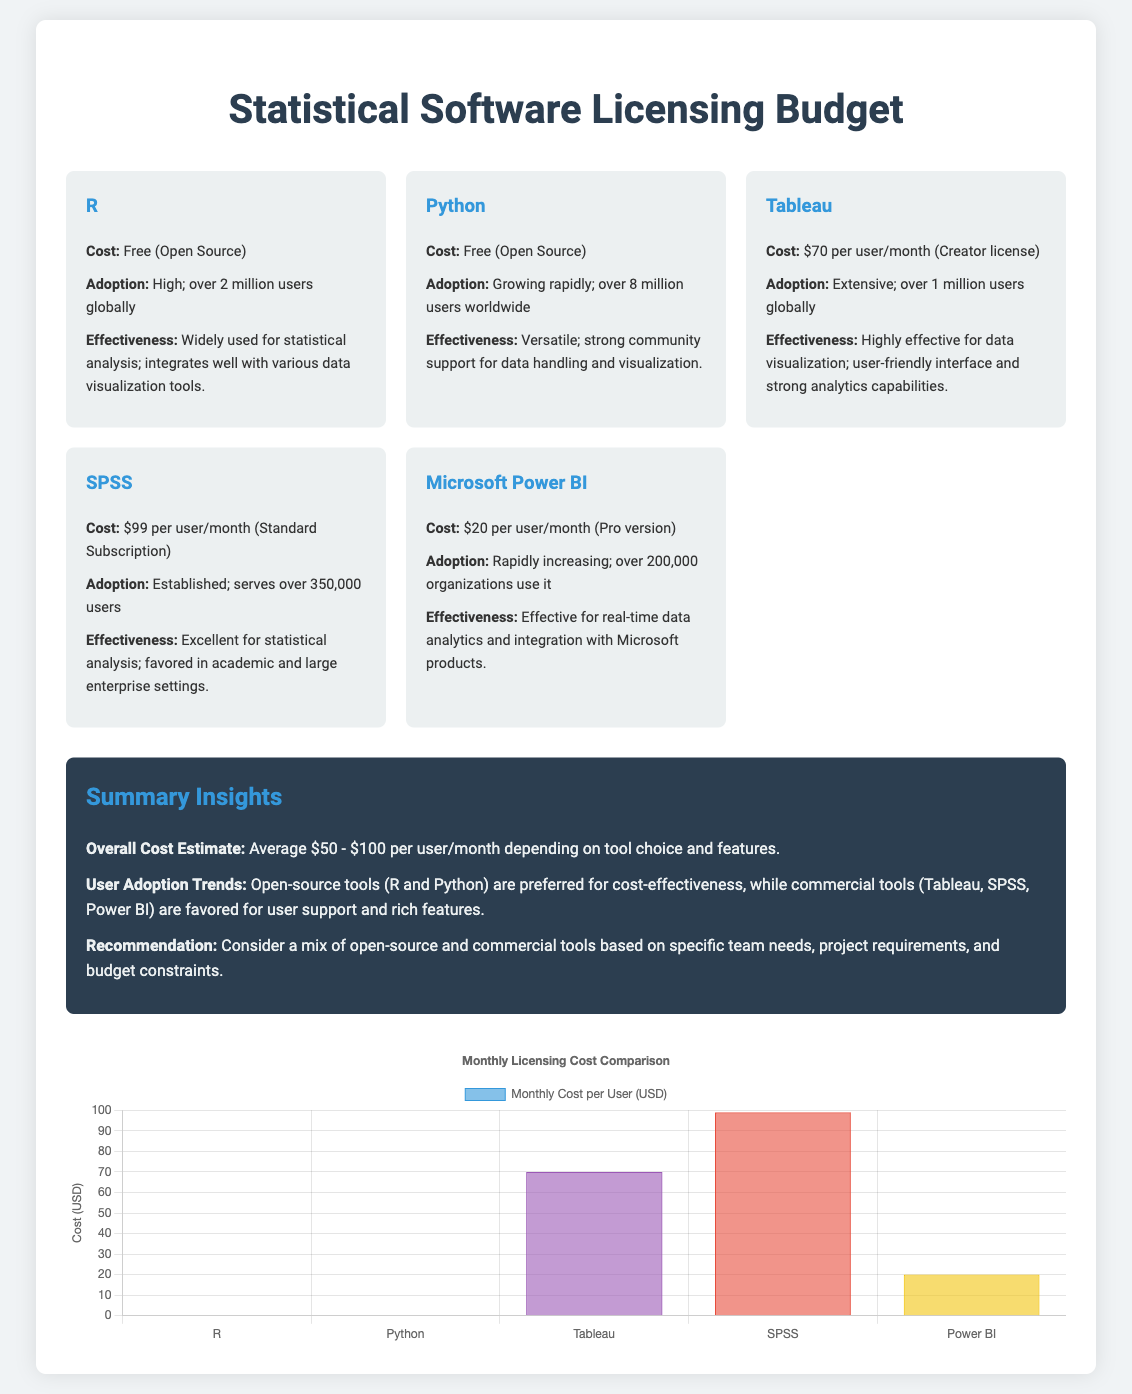What is the cost of Tableau licensing per user? The document states that the cost of Tableau is $70 per user per month.
Answer: $70 per user/month How many users does Python have globally? The document indicates that Python has over 8 million users worldwide.
Answer: Over 8 million users What is the average overall cost estimate range? The summary insight in the document provides an average cost estimate of $50 to $100 per user per month.
Answer: $50 - $100 Which software has the lowest licensing cost? The information on licensing costs reveals that R has no cost as it is open source.
Answer: Free What is the effectiveness of SPSS? The document mentions that SPSS is excellent for statistical analysis and is favored in academic and large enterprise settings.
Answer: Excellent for statistical analysis Which software has the highest user adoption rate? Based on the adoption statistics provided, Python is reported to have the highest user adoption rate with over 8 million users.
Answer: Python What is the total number of users for SPSS? The document specifies that SPSS serves over 350,000 users.
Answer: Over 350,000 users Which two tools are recommended for cost-effectiveness? The summary suggests that R and Python are preferred for their cost-effectiveness as open-source tools.
Answer: R and Python What is the effectiveness of Tableau according to the document? According to the document, Tableau is highly effective for data visualization and has strong analytics capabilities.
Answer: Highly effective for data visualization 